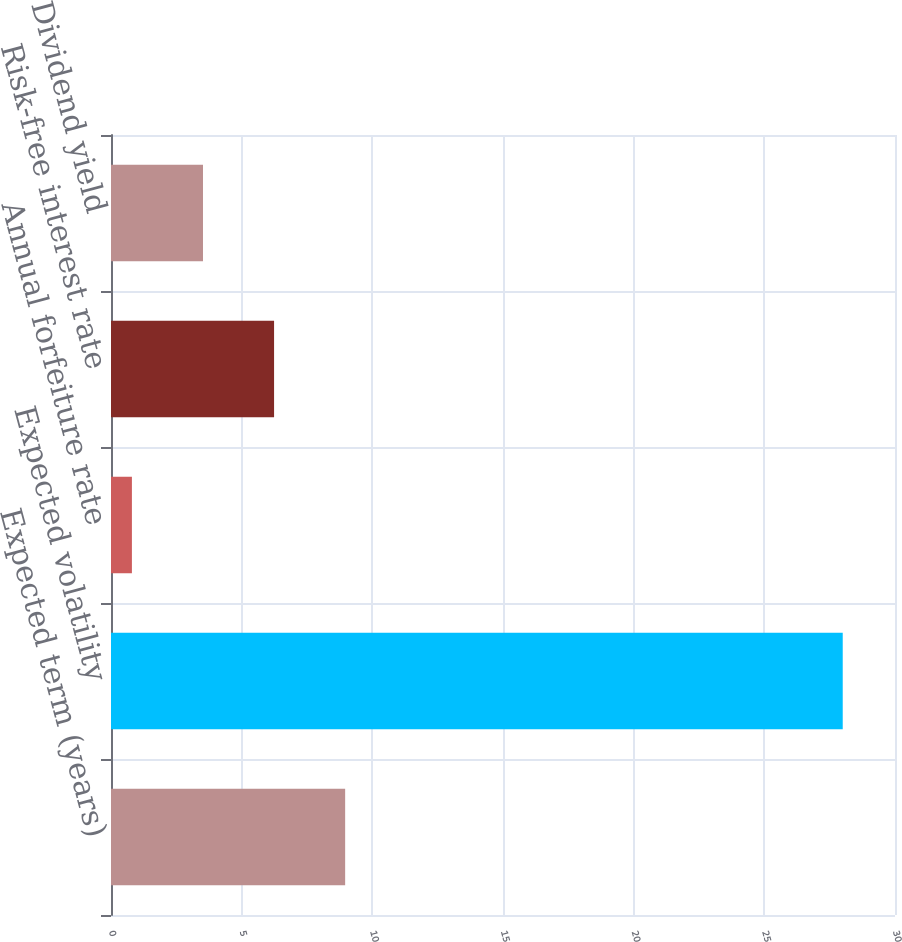<chart> <loc_0><loc_0><loc_500><loc_500><bar_chart><fcel>Expected term (years)<fcel>Expected volatility<fcel>Annual forfeiture rate<fcel>Risk-free interest rate<fcel>Dividend yield<nl><fcel>8.96<fcel>28<fcel>0.8<fcel>6.24<fcel>3.52<nl></chart> 